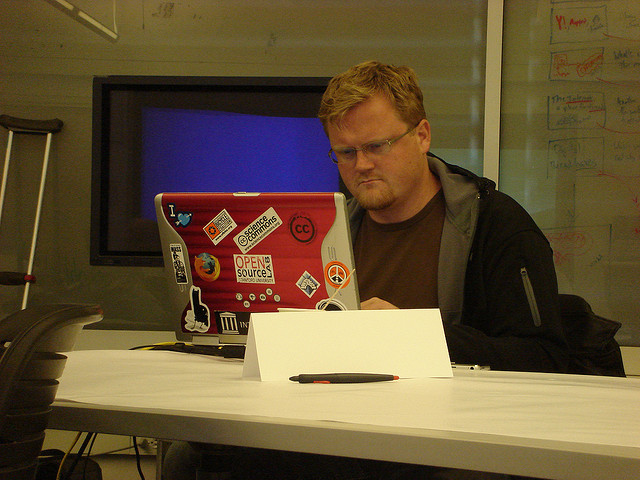<image>What does it say not to do around the computer? It is ambiguous what it says not to do around the computer. The answers suggest both 'open source' and 'eat or drink'. What game is he playing? It is ambiguous what game the person is playing. The game could be anything from Minecraft, Minesweeper, Tetris, Bejeweled, Solitaire to World of Warcraft. What brand is the laptop? I don't know the brand of the laptop. It could possibly be Apple, Acer, or Dell. What I kind of computer is he using? I am not sure what kind of computer he is using. It can be 'laptop', 'apple', or 'dell'. What game is shown behind the laptop? I don't know what game is shown behind the laptop. I cannot see the laptop screen. What is attached to the front of the mirror? It is unknown what is attached to the front of the mirror, as no mirror is visible in the image. What does it say not to do around the computer? I don't know what it says not to do around the computer. There is no information listed. What game is he playing? I don't know the game he is playing. It can be 'minecraft', 'computer', 'minesweeper', 'laptop', 'tetris', 'bejeweled', 'solitaire', or 'wow'. What brand is the laptop? I don't know what brand the laptop is. It could be Apple, Acer, Dell, or Compact. What I kind of computer is he using? I don't know what kind of computer he is using. It can be laptop, apple or dell. What game is shown behind the laptop? I don't know what game is shown behind the laptop. There are multiple possible answers like 'candy crush', 'television' or 'farmville'. What is attached to the front of the mirror? It is unknown what is attached to the front of the mirror. There is no mirror visible in the image. 